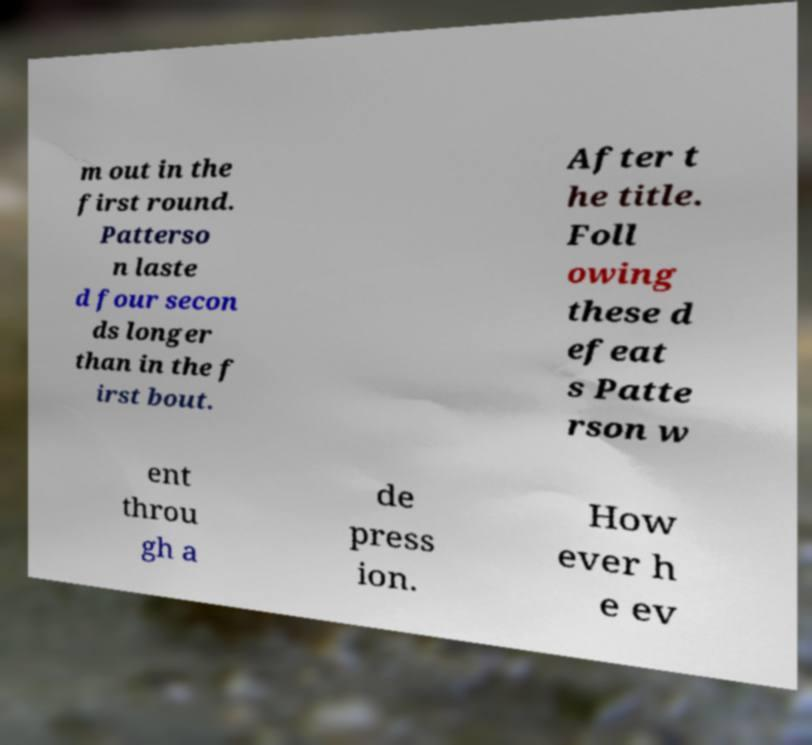Can you read and provide the text displayed in the image?This photo seems to have some interesting text. Can you extract and type it out for me? m out in the first round. Patterso n laste d four secon ds longer than in the f irst bout. After t he title. Foll owing these d efeat s Patte rson w ent throu gh a de press ion. How ever h e ev 